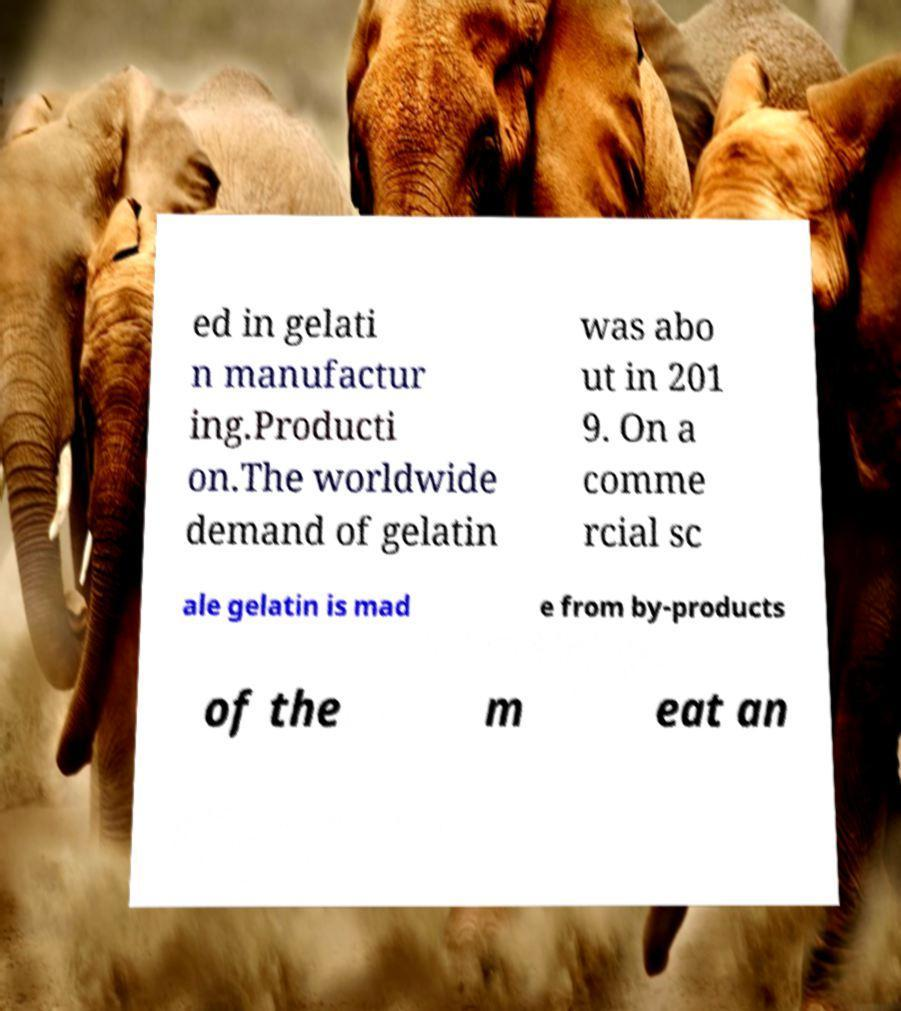Could you assist in decoding the text presented in this image and type it out clearly? ed in gelati n manufactur ing.Producti on.The worldwide demand of gelatin was abo ut in 201 9. On a comme rcial sc ale gelatin is mad e from by-products of the m eat an 